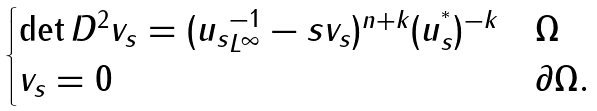Convert formula to latex. <formula><loc_0><loc_0><loc_500><loc_500>\begin{cases} \det D ^ { 2 } v _ { s } = ( \| u _ { s } \| _ { L ^ { \infty } } ^ { - 1 } - s v _ { s } ) ^ { n + k } ( u _ { s } ^ { ^ { * } } ) ^ { - k } & \Omega \\ v _ { s } = 0 & \partial \Omega . \end{cases}</formula> 